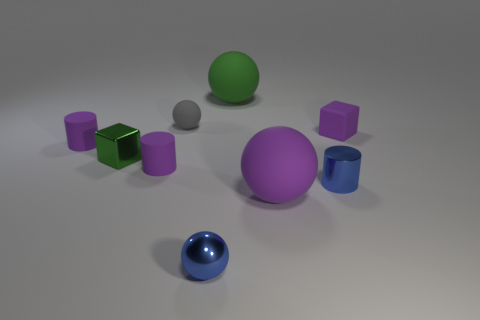Subtract all large green rubber balls. How many balls are left? 3 Subtract all purple spheres. How many spheres are left? 3 Subtract all brown balls. How many yellow blocks are left? 0 Subtract all big matte spheres. Subtract all tiny blue metal cylinders. How many objects are left? 6 Add 1 small shiny blocks. How many small shiny blocks are left? 2 Add 9 large red metallic objects. How many large red metallic objects exist? 9 Subtract 0 cyan cylinders. How many objects are left? 9 Subtract all balls. How many objects are left? 5 Subtract 1 cubes. How many cubes are left? 1 Subtract all cyan cylinders. Subtract all gray cubes. How many cylinders are left? 3 